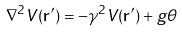<formula> <loc_0><loc_0><loc_500><loc_500>\nabla ^ { 2 } V ( { \mathbf r ^ { \prime } } ) = - \gamma ^ { 2 } V ( { \mathbf r ^ { \prime } } ) + g \theta</formula> 